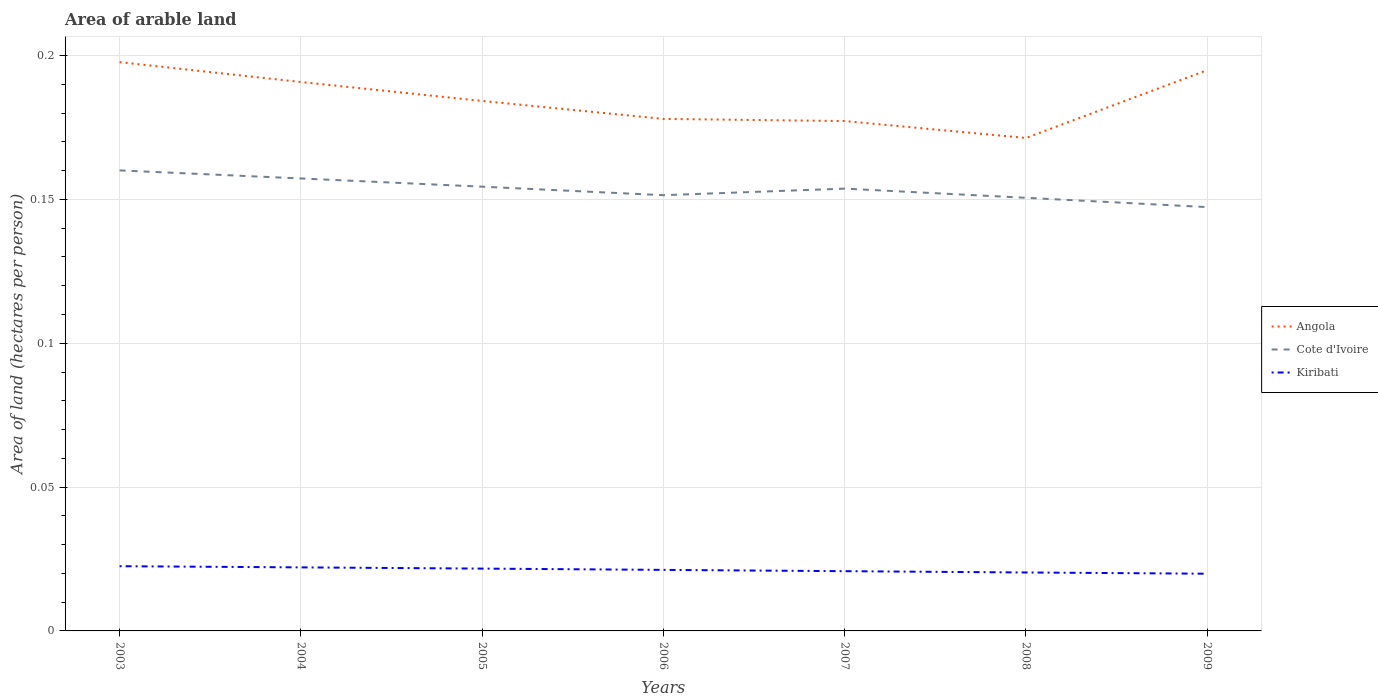How many different coloured lines are there?
Provide a succinct answer. 3. Does the line corresponding to Cote d'Ivoire intersect with the line corresponding to Kiribati?
Keep it short and to the point. No. Across all years, what is the maximum total arable land in Cote d'Ivoire?
Your answer should be very brief. 0.15. What is the total total arable land in Cote d'Ivoire in the graph?
Offer a terse response. 0.01. What is the difference between the highest and the second highest total arable land in Kiribati?
Your response must be concise. 0. How many lines are there?
Offer a terse response. 3. How many years are there in the graph?
Provide a succinct answer. 7. Are the values on the major ticks of Y-axis written in scientific E-notation?
Your response must be concise. No. Does the graph contain any zero values?
Make the answer very short. No. Does the graph contain grids?
Make the answer very short. Yes. How many legend labels are there?
Give a very brief answer. 3. How are the legend labels stacked?
Your response must be concise. Vertical. What is the title of the graph?
Provide a succinct answer. Area of arable land. What is the label or title of the X-axis?
Your answer should be compact. Years. What is the label or title of the Y-axis?
Ensure brevity in your answer.  Area of land (hectares per person). What is the Area of land (hectares per person) in Angola in 2003?
Provide a short and direct response. 0.2. What is the Area of land (hectares per person) of Cote d'Ivoire in 2003?
Provide a short and direct response. 0.16. What is the Area of land (hectares per person) in Kiribati in 2003?
Give a very brief answer. 0.02. What is the Area of land (hectares per person) in Angola in 2004?
Keep it short and to the point. 0.19. What is the Area of land (hectares per person) of Cote d'Ivoire in 2004?
Provide a short and direct response. 0.16. What is the Area of land (hectares per person) in Kiribati in 2004?
Provide a short and direct response. 0.02. What is the Area of land (hectares per person) in Angola in 2005?
Provide a succinct answer. 0.18. What is the Area of land (hectares per person) of Cote d'Ivoire in 2005?
Your response must be concise. 0.15. What is the Area of land (hectares per person) in Kiribati in 2005?
Make the answer very short. 0.02. What is the Area of land (hectares per person) in Angola in 2006?
Ensure brevity in your answer.  0.18. What is the Area of land (hectares per person) of Cote d'Ivoire in 2006?
Your answer should be compact. 0.15. What is the Area of land (hectares per person) in Kiribati in 2006?
Your response must be concise. 0.02. What is the Area of land (hectares per person) in Angola in 2007?
Provide a succinct answer. 0.18. What is the Area of land (hectares per person) in Cote d'Ivoire in 2007?
Offer a terse response. 0.15. What is the Area of land (hectares per person) of Kiribati in 2007?
Your response must be concise. 0.02. What is the Area of land (hectares per person) in Angola in 2008?
Your answer should be very brief. 0.17. What is the Area of land (hectares per person) of Cote d'Ivoire in 2008?
Your answer should be very brief. 0.15. What is the Area of land (hectares per person) in Kiribati in 2008?
Your response must be concise. 0.02. What is the Area of land (hectares per person) of Angola in 2009?
Give a very brief answer. 0.19. What is the Area of land (hectares per person) in Cote d'Ivoire in 2009?
Provide a succinct answer. 0.15. What is the Area of land (hectares per person) in Kiribati in 2009?
Your response must be concise. 0.02. Across all years, what is the maximum Area of land (hectares per person) in Angola?
Your answer should be compact. 0.2. Across all years, what is the maximum Area of land (hectares per person) in Cote d'Ivoire?
Your answer should be compact. 0.16. Across all years, what is the maximum Area of land (hectares per person) in Kiribati?
Keep it short and to the point. 0.02. Across all years, what is the minimum Area of land (hectares per person) in Angola?
Your answer should be very brief. 0.17. Across all years, what is the minimum Area of land (hectares per person) of Cote d'Ivoire?
Keep it short and to the point. 0.15. Across all years, what is the minimum Area of land (hectares per person) in Kiribati?
Ensure brevity in your answer.  0.02. What is the total Area of land (hectares per person) of Angola in the graph?
Provide a succinct answer. 1.29. What is the total Area of land (hectares per person) of Cote d'Ivoire in the graph?
Keep it short and to the point. 1.07. What is the total Area of land (hectares per person) of Kiribati in the graph?
Make the answer very short. 0.15. What is the difference between the Area of land (hectares per person) of Angola in 2003 and that in 2004?
Keep it short and to the point. 0.01. What is the difference between the Area of land (hectares per person) of Cote d'Ivoire in 2003 and that in 2004?
Offer a very short reply. 0. What is the difference between the Area of land (hectares per person) of Kiribati in 2003 and that in 2004?
Offer a terse response. 0. What is the difference between the Area of land (hectares per person) of Angola in 2003 and that in 2005?
Keep it short and to the point. 0.01. What is the difference between the Area of land (hectares per person) in Cote d'Ivoire in 2003 and that in 2005?
Offer a terse response. 0.01. What is the difference between the Area of land (hectares per person) in Kiribati in 2003 and that in 2005?
Offer a very short reply. 0. What is the difference between the Area of land (hectares per person) of Angola in 2003 and that in 2006?
Offer a terse response. 0.02. What is the difference between the Area of land (hectares per person) in Cote d'Ivoire in 2003 and that in 2006?
Offer a very short reply. 0.01. What is the difference between the Area of land (hectares per person) in Kiribati in 2003 and that in 2006?
Ensure brevity in your answer.  0. What is the difference between the Area of land (hectares per person) of Angola in 2003 and that in 2007?
Give a very brief answer. 0.02. What is the difference between the Area of land (hectares per person) in Cote d'Ivoire in 2003 and that in 2007?
Your answer should be compact. 0.01. What is the difference between the Area of land (hectares per person) in Kiribati in 2003 and that in 2007?
Offer a very short reply. 0. What is the difference between the Area of land (hectares per person) in Angola in 2003 and that in 2008?
Make the answer very short. 0.03. What is the difference between the Area of land (hectares per person) of Cote d'Ivoire in 2003 and that in 2008?
Provide a succinct answer. 0.01. What is the difference between the Area of land (hectares per person) in Kiribati in 2003 and that in 2008?
Your answer should be compact. 0. What is the difference between the Area of land (hectares per person) in Angola in 2003 and that in 2009?
Offer a terse response. 0. What is the difference between the Area of land (hectares per person) in Cote d'Ivoire in 2003 and that in 2009?
Provide a succinct answer. 0.01. What is the difference between the Area of land (hectares per person) in Kiribati in 2003 and that in 2009?
Make the answer very short. 0. What is the difference between the Area of land (hectares per person) of Angola in 2004 and that in 2005?
Ensure brevity in your answer.  0.01. What is the difference between the Area of land (hectares per person) of Cote d'Ivoire in 2004 and that in 2005?
Offer a very short reply. 0. What is the difference between the Area of land (hectares per person) of Kiribati in 2004 and that in 2005?
Give a very brief answer. 0. What is the difference between the Area of land (hectares per person) of Angola in 2004 and that in 2006?
Offer a terse response. 0.01. What is the difference between the Area of land (hectares per person) in Cote d'Ivoire in 2004 and that in 2006?
Your answer should be very brief. 0.01. What is the difference between the Area of land (hectares per person) in Kiribati in 2004 and that in 2006?
Provide a succinct answer. 0. What is the difference between the Area of land (hectares per person) in Angola in 2004 and that in 2007?
Offer a very short reply. 0.01. What is the difference between the Area of land (hectares per person) of Cote d'Ivoire in 2004 and that in 2007?
Your response must be concise. 0. What is the difference between the Area of land (hectares per person) in Kiribati in 2004 and that in 2007?
Your answer should be very brief. 0. What is the difference between the Area of land (hectares per person) of Angola in 2004 and that in 2008?
Offer a terse response. 0.02. What is the difference between the Area of land (hectares per person) of Cote d'Ivoire in 2004 and that in 2008?
Provide a short and direct response. 0.01. What is the difference between the Area of land (hectares per person) of Kiribati in 2004 and that in 2008?
Keep it short and to the point. 0. What is the difference between the Area of land (hectares per person) of Angola in 2004 and that in 2009?
Your answer should be very brief. -0. What is the difference between the Area of land (hectares per person) of Kiribati in 2004 and that in 2009?
Provide a short and direct response. 0. What is the difference between the Area of land (hectares per person) in Angola in 2005 and that in 2006?
Your answer should be very brief. 0.01. What is the difference between the Area of land (hectares per person) in Cote d'Ivoire in 2005 and that in 2006?
Your answer should be very brief. 0. What is the difference between the Area of land (hectares per person) in Angola in 2005 and that in 2007?
Give a very brief answer. 0.01. What is the difference between the Area of land (hectares per person) in Cote d'Ivoire in 2005 and that in 2007?
Your answer should be very brief. 0. What is the difference between the Area of land (hectares per person) of Kiribati in 2005 and that in 2007?
Make the answer very short. 0. What is the difference between the Area of land (hectares per person) of Angola in 2005 and that in 2008?
Offer a terse response. 0.01. What is the difference between the Area of land (hectares per person) in Cote d'Ivoire in 2005 and that in 2008?
Keep it short and to the point. 0. What is the difference between the Area of land (hectares per person) in Kiribati in 2005 and that in 2008?
Offer a terse response. 0. What is the difference between the Area of land (hectares per person) of Angola in 2005 and that in 2009?
Ensure brevity in your answer.  -0.01. What is the difference between the Area of land (hectares per person) in Cote d'Ivoire in 2005 and that in 2009?
Give a very brief answer. 0.01. What is the difference between the Area of land (hectares per person) in Kiribati in 2005 and that in 2009?
Offer a very short reply. 0. What is the difference between the Area of land (hectares per person) in Angola in 2006 and that in 2007?
Ensure brevity in your answer.  0. What is the difference between the Area of land (hectares per person) of Cote d'Ivoire in 2006 and that in 2007?
Offer a terse response. -0. What is the difference between the Area of land (hectares per person) of Angola in 2006 and that in 2008?
Ensure brevity in your answer.  0.01. What is the difference between the Area of land (hectares per person) of Cote d'Ivoire in 2006 and that in 2008?
Make the answer very short. 0. What is the difference between the Area of land (hectares per person) in Kiribati in 2006 and that in 2008?
Your answer should be compact. 0. What is the difference between the Area of land (hectares per person) in Angola in 2006 and that in 2009?
Ensure brevity in your answer.  -0.02. What is the difference between the Area of land (hectares per person) of Cote d'Ivoire in 2006 and that in 2009?
Offer a terse response. 0. What is the difference between the Area of land (hectares per person) in Kiribati in 2006 and that in 2009?
Provide a short and direct response. 0. What is the difference between the Area of land (hectares per person) in Angola in 2007 and that in 2008?
Ensure brevity in your answer.  0.01. What is the difference between the Area of land (hectares per person) of Cote d'Ivoire in 2007 and that in 2008?
Keep it short and to the point. 0. What is the difference between the Area of land (hectares per person) of Kiribati in 2007 and that in 2008?
Give a very brief answer. 0. What is the difference between the Area of land (hectares per person) in Angola in 2007 and that in 2009?
Make the answer very short. -0.02. What is the difference between the Area of land (hectares per person) of Cote d'Ivoire in 2007 and that in 2009?
Make the answer very short. 0.01. What is the difference between the Area of land (hectares per person) of Kiribati in 2007 and that in 2009?
Offer a very short reply. 0. What is the difference between the Area of land (hectares per person) in Angola in 2008 and that in 2009?
Your answer should be very brief. -0.02. What is the difference between the Area of land (hectares per person) in Cote d'Ivoire in 2008 and that in 2009?
Provide a short and direct response. 0. What is the difference between the Area of land (hectares per person) in Angola in 2003 and the Area of land (hectares per person) in Cote d'Ivoire in 2004?
Provide a succinct answer. 0.04. What is the difference between the Area of land (hectares per person) in Angola in 2003 and the Area of land (hectares per person) in Kiribati in 2004?
Make the answer very short. 0.18. What is the difference between the Area of land (hectares per person) in Cote d'Ivoire in 2003 and the Area of land (hectares per person) in Kiribati in 2004?
Your answer should be very brief. 0.14. What is the difference between the Area of land (hectares per person) in Angola in 2003 and the Area of land (hectares per person) in Cote d'Ivoire in 2005?
Your answer should be compact. 0.04. What is the difference between the Area of land (hectares per person) in Angola in 2003 and the Area of land (hectares per person) in Kiribati in 2005?
Your answer should be very brief. 0.18. What is the difference between the Area of land (hectares per person) in Cote d'Ivoire in 2003 and the Area of land (hectares per person) in Kiribati in 2005?
Your answer should be very brief. 0.14. What is the difference between the Area of land (hectares per person) in Angola in 2003 and the Area of land (hectares per person) in Cote d'Ivoire in 2006?
Provide a short and direct response. 0.05. What is the difference between the Area of land (hectares per person) of Angola in 2003 and the Area of land (hectares per person) of Kiribati in 2006?
Ensure brevity in your answer.  0.18. What is the difference between the Area of land (hectares per person) in Cote d'Ivoire in 2003 and the Area of land (hectares per person) in Kiribati in 2006?
Your answer should be compact. 0.14. What is the difference between the Area of land (hectares per person) in Angola in 2003 and the Area of land (hectares per person) in Cote d'Ivoire in 2007?
Your response must be concise. 0.04. What is the difference between the Area of land (hectares per person) of Angola in 2003 and the Area of land (hectares per person) of Kiribati in 2007?
Your answer should be very brief. 0.18. What is the difference between the Area of land (hectares per person) in Cote d'Ivoire in 2003 and the Area of land (hectares per person) in Kiribati in 2007?
Offer a terse response. 0.14. What is the difference between the Area of land (hectares per person) in Angola in 2003 and the Area of land (hectares per person) in Cote d'Ivoire in 2008?
Your answer should be very brief. 0.05. What is the difference between the Area of land (hectares per person) of Angola in 2003 and the Area of land (hectares per person) of Kiribati in 2008?
Your answer should be very brief. 0.18. What is the difference between the Area of land (hectares per person) of Cote d'Ivoire in 2003 and the Area of land (hectares per person) of Kiribati in 2008?
Provide a succinct answer. 0.14. What is the difference between the Area of land (hectares per person) of Angola in 2003 and the Area of land (hectares per person) of Cote d'Ivoire in 2009?
Provide a succinct answer. 0.05. What is the difference between the Area of land (hectares per person) of Angola in 2003 and the Area of land (hectares per person) of Kiribati in 2009?
Your answer should be very brief. 0.18. What is the difference between the Area of land (hectares per person) in Cote d'Ivoire in 2003 and the Area of land (hectares per person) in Kiribati in 2009?
Your answer should be very brief. 0.14. What is the difference between the Area of land (hectares per person) of Angola in 2004 and the Area of land (hectares per person) of Cote d'Ivoire in 2005?
Keep it short and to the point. 0.04. What is the difference between the Area of land (hectares per person) in Angola in 2004 and the Area of land (hectares per person) in Kiribati in 2005?
Ensure brevity in your answer.  0.17. What is the difference between the Area of land (hectares per person) of Cote d'Ivoire in 2004 and the Area of land (hectares per person) of Kiribati in 2005?
Provide a short and direct response. 0.14. What is the difference between the Area of land (hectares per person) of Angola in 2004 and the Area of land (hectares per person) of Cote d'Ivoire in 2006?
Offer a terse response. 0.04. What is the difference between the Area of land (hectares per person) of Angola in 2004 and the Area of land (hectares per person) of Kiribati in 2006?
Your answer should be very brief. 0.17. What is the difference between the Area of land (hectares per person) in Cote d'Ivoire in 2004 and the Area of land (hectares per person) in Kiribati in 2006?
Offer a very short reply. 0.14. What is the difference between the Area of land (hectares per person) in Angola in 2004 and the Area of land (hectares per person) in Cote d'Ivoire in 2007?
Keep it short and to the point. 0.04. What is the difference between the Area of land (hectares per person) in Angola in 2004 and the Area of land (hectares per person) in Kiribati in 2007?
Keep it short and to the point. 0.17. What is the difference between the Area of land (hectares per person) of Cote d'Ivoire in 2004 and the Area of land (hectares per person) of Kiribati in 2007?
Your response must be concise. 0.14. What is the difference between the Area of land (hectares per person) in Angola in 2004 and the Area of land (hectares per person) in Cote d'Ivoire in 2008?
Make the answer very short. 0.04. What is the difference between the Area of land (hectares per person) in Angola in 2004 and the Area of land (hectares per person) in Kiribati in 2008?
Offer a very short reply. 0.17. What is the difference between the Area of land (hectares per person) in Cote d'Ivoire in 2004 and the Area of land (hectares per person) in Kiribati in 2008?
Your response must be concise. 0.14. What is the difference between the Area of land (hectares per person) of Angola in 2004 and the Area of land (hectares per person) of Cote d'Ivoire in 2009?
Offer a terse response. 0.04. What is the difference between the Area of land (hectares per person) of Angola in 2004 and the Area of land (hectares per person) of Kiribati in 2009?
Offer a very short reply. 0.17. What is the difference between the Area of land (hectares per person) of Cote d'Ivoire in 2004 and the Area of land (hectares per person) of Kiribati in 2009?
Offer a terse response. 0.14. What is the difference between the Area of land (hectares per person) of Angola in 2005 and the Area of land (hectares per person) of Cote d'Ivoire in 2006?
Ensure brevity in your answer.  0.03. What is the difference between the Area of land (hectares per person) of Angola in 2005 and the Area of land (hectares per person) of Kiribati in 2006?
Provide a succinct answer. 0.16. What is the difference between the Area of land (hectares per person) in Cote d'Ivoire in 2005 and the Area of land (hectares per person) in Kiribati in 2006?
Your answer should be compact. 0.13. What is the difference between the Area of land (hectares per person) of Angola in 2005 and the Area of land (hectares per person) of Cote d'Ivoire in 2007?
Your response must be concise. 0.03. What is the difference between the Area of land (hectares per person) of Angola in 2005 and the Area of land (hectares per person) of Kiribati in 2007?
Ensure brevity in your answer.  0.16. What is the difference between the Area of land (hectares per person) of Cote d'Ivoire in 2005 and the Area of land (hectares per person) of Kiribati in 2007?
Provide a short and direct response. 0.13. What is the difference between the Area of land (hectares per person) in Angola in 2005 and the Area of land (hectares per person) in Cote d'Ivoire in 2008?
Keep it short and to the point. 0.03. What is the difference between the Area of land (hectares per person) in Angola in 2005 and the Area of land (hectares per person) in Kiribati in 2008?
Offer a very short reply. 0.16. What is the difference between the Area of land (hectares per person) in Cote d'Ivoire in 2005 and the Area of land (hectares per person) in Kiribati in 2008?
Provide a short and direct response. 0.13. What is the difference between the Area of land (hectares per person) of Angola in 2005 and the Area of land (hectares per person) of Cote d'Ivoire in 2009?
Offer a terse response. 0.04. What is the difference between the Area of land (hectares per person) in Angola in 2005 and the Area of land (hectares per person) in Kiribati in 2009?
Your response must be concise. 0.16. What is the difference between the Area of land (hectares per person) of Cote d'Ivoire in 2005 and the Area of land (hectares per person) of Kiribati in 2009?
Offer a terse response. 0.13. What is the difference between the Area of land (hectares per person) in Angola in 2006 and the Area of land (hectares per person) in Cote d'Ivoire in 2007?
Offer a terse response. 0.02. What is the difference between the Area of land (hectares per person) of Angola in 2006 and the Area of land (hectares per person) of Kiribati in 2007?
Keep it short and to the point. 0.16. What is the difference between the Area of land (hectares per person) in Cote d'Ivoire in 2006 and the Area of land (hectares per person) in Kiribati in 2007?
Ensure brevity in your answer.  0.13. What is the difference between the Area of land (hectares per person) of Angola in 2006 and the Area of land (hectares per person) of Cote d'Ivoire in 2008?
Provide a succinct answer. 0.03. What is the difference between the Area of land (hectares per person) in Angola in 2006 and the Area of land (hectares per person) in Kiribati in 2008?
Your response must be concise. 0.16. What is the difference between the Area of land (hectares per person) in Cote d'Ivoire in 2006 and the Area of land (hectares per person) in Kiribati in 2008?
Keep it short and to the point. 0.13. What is the difference between the Area of land (hectares per person) of Angola in 2006 and the Area of land (hectares per person) of Cote d'Ivoire in 2009?
Your answer should be very brief. 0.03. What is the difference between the Area of land (hectares per person) of Angola in 2006 and the Area of land (hectares per person) of Kiribati in 2009?
Your answer should be compact. 0.16. What is the difference between the Area of land (hectares per person) in Cote d'Ivoire in 2006 and the Area of land (hectares per person) in Kiribati in 2009?
Offer a very short reply. 0.13. What is the difference between the Area of land (hectares per person) of Angola in 2007 and the Area of land (hectares per person) of Cote d'Ivoire in 2008?
Your answer should be compact. 0.03. What is the difference between the Area of land (hectares per person) in Angola in 2007 and the Area of land (hectares per person) in Kiribati in 2008?
Offer a terse response. 0.16. What is the difference between the Area of land (hectares per person) of Cote d'Ivoire in 2007 and the Area of land (hectares per person) of Kiribati in 2008?
Provide a succinct answer. 0.13. What is the difference between the Area of land (hectares per person) of Angola in 2007 and the Area of land (hectares per person) of Cote d'Ivoire in 2009?
Your answer should be very brief. 0.03. What is the difference between the Area of land (hectares per person) of Angola in 2007 and the Area of land (hectares per person) of Kiribati in 2009?
Your response must be concise. 0.16. What is the difference between the Area of land (hectares per person) of Cote d'Ivoire in 2007 and the Area of land (hectares per person) of Kiribati in 2009?
Keep it short and to the point. 0.13. What is the difference between the Area of land (hectares per person) of Angola in 2008 and the Area of land (hectares per person) of Cote d'Ivoire in 2009?
Your answer should be very brief. 0.02. What is the difference between the Area of land (hectares per person) of Angola in 2008 and the Area of land (hectares per person) of Kiribati in 2009?
Give a very brief answer. 0.15. What is the difference between the Area of land (hectares per person) in Cote d'Ivoire in 2008 and the Area of land (hectares per person) in Kiribati in 2009?
Provide a short and direct response. 0.13. What is the average Area of land (hectares per person) in Angola per year?
Offer a very short reply. 0.18. What is the average Area of land (hectares per person) of Cote d'Ivoire per year?
Give a very brief answer. 0.15. What is the average Area of land (hectares per person) of Kiribati per year?
Your answer should be compact. 0.02. In the year 2003, what is the difference between the Area of land (hectares per person) in Angola and Area of land (hectares per person) in Cote d'Ivoire?
Your answer should be very brief. 0.04. In the year 2003, what is the difference between the Area of land (hectares per person) of Angola and Area of land (hectares per person) of Kiribati?
Provide a short and direct response. 0.18. In the year 2003, what is the difference between the Area of land (hectares per person) in Cote d'Ivoire and Area of land (hectares per person) in Kiribati?
Ensure brevity in your answer.  0.14. In the year 2004, what is the difference between the Area of land (hectares per person) of Angola and Area of land (hectares per person) of Cote d'Ivoire?
Make the answer very short. 0.03. In the year 2004, what is the difference between the Area of land (hectares per person) in Angola and Area of land (hectares per person) in Kiribati?
Provide a succinct answer. 0.17. In the year 2004, what is the difference between the Area of land (hectares per person) of Cote d'Ivoire and Area of land (hectares per person) of Kiribati?
Offer a very short reply. 0.14. In the year 2005, what is the difference between the Area of land (hectares per person) in Angola and Area of land (hectares per person) in Cote d'Ivoire?
Offer a very short reply. 0.03. In the year 2005, what is the difference between the Area of land (hectares per person) of Angola and Area of land (hectares per person) of Kiribati?
Ensure brevity in your answer.  0.16. In the year 2005, what is the difference between the Area of land (hectares per person) in Cote d'Ivoire and Area of land (hectares per person) in Kiribati?
Ensure brevity in your answer.  0.13. In the year 2006, what is the difference between the Area of land (hectares per person) of Angola and Area of land (hectares per person) of Cote d'Ivoire?
Provide a short and direct response. 0.03. In the year 2006, what is the difference between the Area of land (hectares per person) of Angola and Area of land (hectares per person) of Kiribati?
Keep it short and to the point. 0.16. In the year 2006, what is the difference between the Area of land (hectares per person) of Cote d'Ivoire and Area of land (hectares per person) of Kiribati?
Provide a succinct answer. 0.13. In the year 2007, what is the difference between the Area of land (hectares per person) in Angola and Area of land (hectares per person) in Cote d'Ivoire?
Provide a succinct answer. 0.02. In the year 2007, what is the difference between the Area of land (hectares per person) of Angola and Area of land (hectares per person) of Kiribati?
Ensure brevity in your answer.  0.16. In the year 2007, what is the difference between the Area of land (hectares per person) in Cote d'Ivoire and Area of land (hectares per person) in Kiribati?
Keep it short and to the point. 0.13. In the year 2008, what is the difference between the Area of land (hectares per person) of Angola and Area of land (hectares per person) of Cote d'Ivoire?
Your response must be concise. 0.02. In the year 2008, what is the difference between the Area of land (hectares per person) in Angola and Area of land (hectares per person) in Kiribati?
Provide a short and direct response. 0.15. In the year 2008, what is the difference between the Area of land (hectares per person) of Cote d'Ivoire and Area of land (hectares per person) of Kiribati?
Ensure brevity in your answer.  0.13. In the year 2009, what is the difference between the Area of land (hectares per person) in Angola and Area of land (hectares per person) in Cote d'Ivoire?
Your response must be concise. 0.05. In the year 2009, what is the difference between the Area of land (hectares per person) in Angola and Area of land (hectares per person) in Kiribati?
Your answer should be very brief. 0.17. In the year 2009, what is the difference between the Area of land (hectares per person) of Cote d'Ivoire and Area of land (hectares per person) of Kiribati?
Offer a terse response. 0.13. What is the ratio of the Area of land (hectares per person) in Angola in 2003 to that in 2004?
Provide a succinct answer. 1.04. What is the ratio of the Area of land (hectares per person) in Cote d'Ivoire in 2003 to that in 2004?
Provide a succinct answer. 1.02. What is the ratio of the Area of land (hectares per person) of Kiribati in 2003 to that in 2004?
Provide a short and direct response. 1.02. What is the ratio of the Area of land (hectares per person) in Angola in 2003 to that in 2005?
Give a very brief answer. 1.07. What is the ratio of the Area of land (hectares per person) of Cote d'Ivoire in 2003 to that in 2005?
Keep it short and to the point. 1.04. What is the ratio of the Area of land (hectares per person) in Kiribati in 2003 to that in 2005?
Provide a short and direct response. 1.04. What is the ratio of the Area of land (hectares per person) of Angola in 2003 to that in 2006?
Provide a succinct answer. 1.11. What is the ratio of the Area of land (hectares per person) in Cote d'Ivoire in 2003 to that in 2006?
Offer a very short reply. 1.06. What is the ratio of the Area of land (hectares per person) in Kiribati in 2003 to that in 2006?
Provide a succinct answer. 1.06. What is the ratio of the Area of land (hectares per person) in Angola in 2003 to that in 2007?
Provide a short and direct response. 1.12. What is the ratio of the Area of land (hectares per person) in Cote d'Ivoire in 2003 to that in 2007?
Make the answer very short. 1.04. What is the ratio of the Area of land (hectares per person) of Kiribati in 2003 to that in 2007?
Your answer should be very brief. 1.08. What is the ratio of the Area of land (hectares per person) in Angola in 2003 to that in 2008?
Your response must be concise. 1.15. What is the ratio of the Area of land (hectares per person) of Cote d'Ivoire in 2003 to that in 2008?
Your response must be concise. 1.06. What is the ratio of the Area of land (hectares per person) in Kiribati in 2003 to that in 2008?
Your response must be concise. 1.11. What is the ratio of the Area of land (hectares per person) in Angola in 2003 to that in 2009?
Offer a very short reply. 1.01. What is the ratio of the Area of land (hectares per person) of Cote d'Ivoire in 2003 to that in 2009?
Your response must be concise. 1.09. What is the ratio of the Area of land (hectares per person) in Kiribati in 2003 to that in 2009?
Give a very brief answer. 1.13. What is the ratio of the Area of land (hectares per person) in Angola in 2004 to that in 2005?
Provide a succinct answer. 1.04. What is the ratio of the Area of land (hectares per person) of Cote d'Ivoire in 2004 to that in 2005?
Make the answer very short. 1.02. What is the ratio of the Area of land (hectares per person) of Kiribati in 2004 to that in 2005?
Your answer should be compact. 1.02. What is the ratio of the Area of land (hectares per person) in Angola in 2004 to that in 2006?
Offer a very short reply. 1.07. What is the ratio of the Area of land (hectares per person) in Cote d'Ivoire in 2004 to that in 2006?
Offer a very short reply. 1.04. What is the ratio of the Area of land (hectares per person) of Kiribati in 2004 to that in 2006?
Offer a very short reply. 1.04. What is the ratio of the Area of land (hectares per person) in Angola in 2004 to that in 2007?
Provide a succinct answer. 1.08. What is the ratio of the Area of land (hectares per person) in Cote d'Ivoire in 2004 to that in 2007?
Provide a short and direct response. 1.02. What is the ratio of the Area of land (hectares per person) in Kiribati in 2004 to that in 2007?
Provide a short and direct response. 1.06. What is the ratio of the Area of land (hectares per person) of Angola in 2004 to that in 2008?
Make the answer very short. 1.11. What is the ratio of the Area of land (hectares per person) of Cote d'Ivoire in 2004 to that in 2008?
Your answer should be very brief. 1.04. What is the ratio of the Area of land (hectares per person) of Kiribati in 2004 to that in 2008?
Your answer should be compact. 1.09. What is the ratio of the Area of land (hectares per person) in Angola in 2004 to that in 2009?
Offer a very short reply. 0.98. What is the ratio of the Area of land (hectares per person) of Cote d'Ivoire in 2004 to that in 2009?
Ensure brevity in your answer.  1.07. What is the ratio of the Area of land (hectares per person) in Kiribati in 2004 to that in 2009?
Offer a very short reply. 1.11. What is the ratio of the Area of land (hectares per person) in Angola in 2005 to that in 2006?
Ensure brevity in your answer.  1.04. What is the ratio of the Area of land (hectares per person) in Cote d'Ivoire in 2005 to that in 2006?
Offer a very short reply. 1.02. What is the ratio of the Area of land (hectares per person) of Kiribati in 2005 to that in 2006?
Your answer should be very brief. 1.02. What is the ratio of the Area of land (hectares per person) in Angola in 2005 to that in 2007?
Offer a very short reply. 1.04. What is the ratio of the Area of land (hectares per person) in Kiribati in 2005 to that in 2007?
Provide a succinct answer. 1.04. What is the ratio of the Area of land (hectares per person) of Angola in 2005 to that in 2008?
Keep it short and to the point. 1.08. What is the ratio of the Area of land (hectares per person) in Cote d'Ivoire in 2005 to that in 2008?
Your answer should be compact. 1.03. What is the ratio of the Area of land (hectares per person) of Kiribati in 2005 to that in 2008?
Keep it short and to the point. 1.07. What is the ratio of the Area of land (hectares per person) in Angola in 2005 to that in 2009?
Your response must be concise. 0.95. What is the ratio of the Area of land (hectares per person) of Cote d'Ivoire in 2005 to that in 2009?
Offer a very short reply. 1.05. What is the ratio of the Area of land (hectares per person) of Kiribati in 2005 to that in 2009?
Offer a terse response. 1.09. What is the ratio of the Area of land (hectares per person) of Angola in 2006 to that in 2007?
Your response must be concise. 1. What is the ratio of the Area of land (hectares per person) of Cote d'Ivoire in 2006 to that in 2007?
Keep it short and to the point. 0.99. What is the ratio of the Area of land (hectares per person) in Kiribati in 2006 to that in 2007?
Make the answer very short. 1.02. What is the ratio of the Area of land (hectares per person) in Angola in 2006 to that in 2008?
Ensure brevity in your answer.  1.04. What is the ratio of the Area of land (hectares per person) in Kiribati in 2006 to that in 2008?
Give a very brief answer. 1.04. What is the ratio of the Area of land (hectares per person) of Cote d'Ivoire in 2006 to that in 2009?
Offer a very short reply. 1.03. What is the ratio of the Area of land (hectares per person) of Kiribati in 2006 to that in 2009?
Offer a terse response. 1.07. What is the ratio of the Area of land (hectares per person) of Angola in 2007 to that in 2008?
Provide a succinct answer. 1.03. What is the ratio of the Area of land (hectares per person) of Cote d'Ivoire in 2007 to that in 2008?
Make the answer very short. 1.02. What is the ratio of the Area of land (hectares per person) in Kiribati in 2007 to that in 2008?
Offer a very short reply. 1.02. What is the ratio of the Area of land (hectares per person) in Angola in 2007 to that in 2009?
Provide a succinct answer. 0.91. What is the ratio of the Area of land (hectares per person) in Cote d'Ivoire in 2007 to that in 2009?
Your answer should be compact. 1.04. What is the ratio of the Area of land (hectares per person) of Kiribati in 2007 to that in 2009?
Keep it short and to the point. 1.04. What is the ratio of the Area of land (hectares per person) in Angola in 2008 to that in 2009?
Give a very brief answer. 0.88. What is the ratio of the Area of land (hectares per person) of Kiribati in 2008 to that in 2009?
Offer a terse response. 1.02. What is the difference between the highest and the second highest Area of land (hectares per person) in Angola?
Your answer should be very brief. 0. What is the difference between the highest and the second highest Area of land (hectares per person) of Cote d'Ivoire?
Make the answer very short. 0. What is the difference between the highest and the second highest Area of land (hectares per person) of Kiribati?
Your answer should be very brief. 0. What is the difference between the highest and the lowest Area of land (hectares per person) of Angola?
Offer a terse response. 0.03. What is the difference between the highest and the lowest Area of land (hectares per person) in Cote d'Ivoire?
Provide a short and direct response. 0.01. What is the difference between the highest and the lowest Area of land (hectares per person) in Kiribati?
Offer a terse response. 0. 